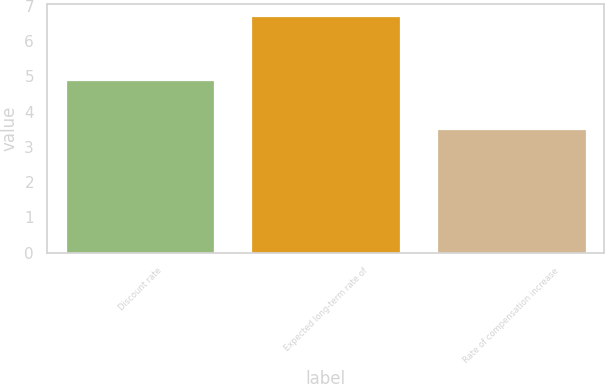Convert chart. <chart><loc_0><loc_0><loc_500><loc_500><bar_chart><fcel>Discount rate<fcel>Expected long-term rate of<fcel>Rate of compensation increase<nl><fcel>4.9<fcel>6.7<fcel>3.5<nl></chart> 